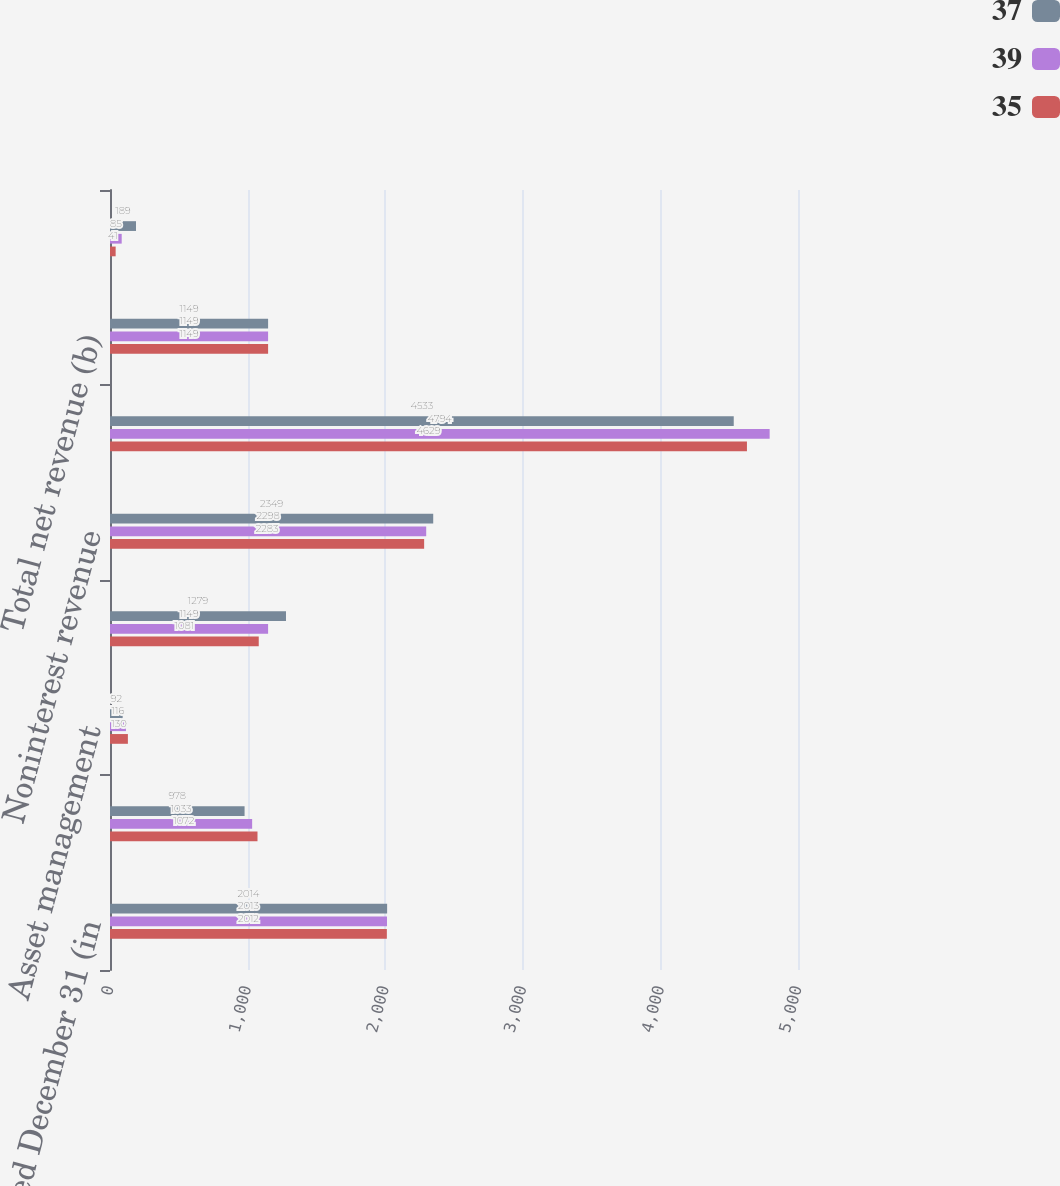<chart> <loc_0><loc_0><loc_500><loc_500><stacked_bar_chart><ecel><fcel>Year ended December 31 (in<fcel>Lending- and deposit-related<fcel>Asset management<fcel>All other income (a)<fcel>Noninterest revenue<fcel>Net interest income<fcel>Total net revenue (b)<fcel>Provision for credit losses<nl><fcel>37<fcel>2014<fcel>978<fcel>92<fcel>1279<fcel>2349<fcel>4533<fcel>1149<fcel>189<nl><fcel>39<fcel>2013<fcel>1033<fcel>116<fcel>1149<fcel>2298<fcel>4794<fcel>1149<fcel>85<nl><fcel>35<fcel>2012<fcel>1072<fcel>130<fcel>1081<fcel>2283<fcel>4629<fcel>1149<fcel>41<nl></chart> 